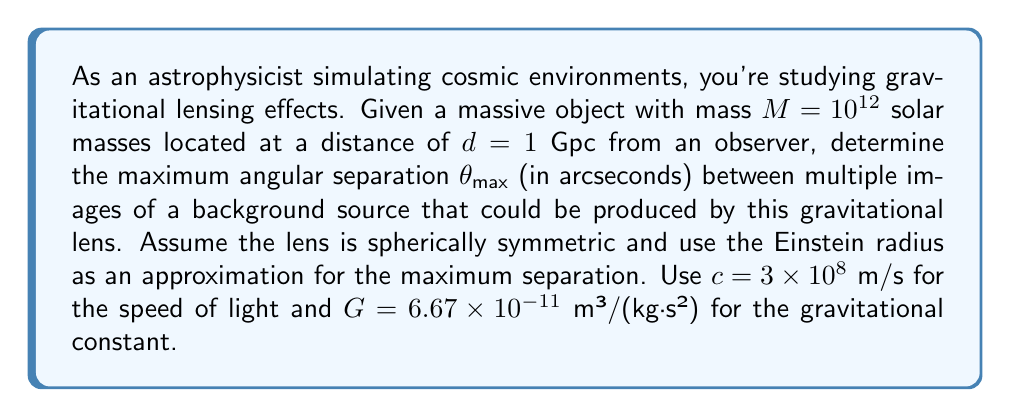What is the answer to this math problem? To solve this problem, we'll use the concept of the Einstein radius, which provides a good approximation for the maximum angular separation between multiple images in a gravitational lensing system.

1) First, we need to convert the given mass to kilograms:
   $M = 10^{12}$ solar masses = $10^{12} \times (1.989 \times 10^{30})$ kg = $1.989 \times 10^{42}$ kg

2) The distance needs to be converted to meters:
   $d = 1$ Gpc = $3.086 \times 10^{25}$ m

3) The Einstein radius in radians is given by the formula:

   $$\theta_E = \sqrt{\frac{4GM}{c^2d}}$$

4) Substituting the values:

   $$\theta_E = \sqrt{\frac{4 \times (6.67 \times 10^{-11}) \times (1.989 \times 10^{42})}{(3 \times 10^8)^2 \times (3.086 \times 10^{25})}}$$

5) Simplifying:

   $$\theta_E = \sqrt{\frac{5.30 \times 10^{32}}{2.78 \times 10^{42}}} = \sqrt{1.91 \times 10^{-10}} = 1.38 \times 10^{-5}$$ radians

6) Convert to arcseconds:
   $\theta_{max} = \theta_E \times \frac{180}{\pi} \times 3600 = 1.38 \times 10^{-5} \times \frac{180}{\pi} \times 3600 = 2.85$ arcseconds

Therefore, the maximum angular separation between multiple images is approximately 2.85 arcseconds.
Answer: $\theta_{max} \approx 2.85$ arcseconds 